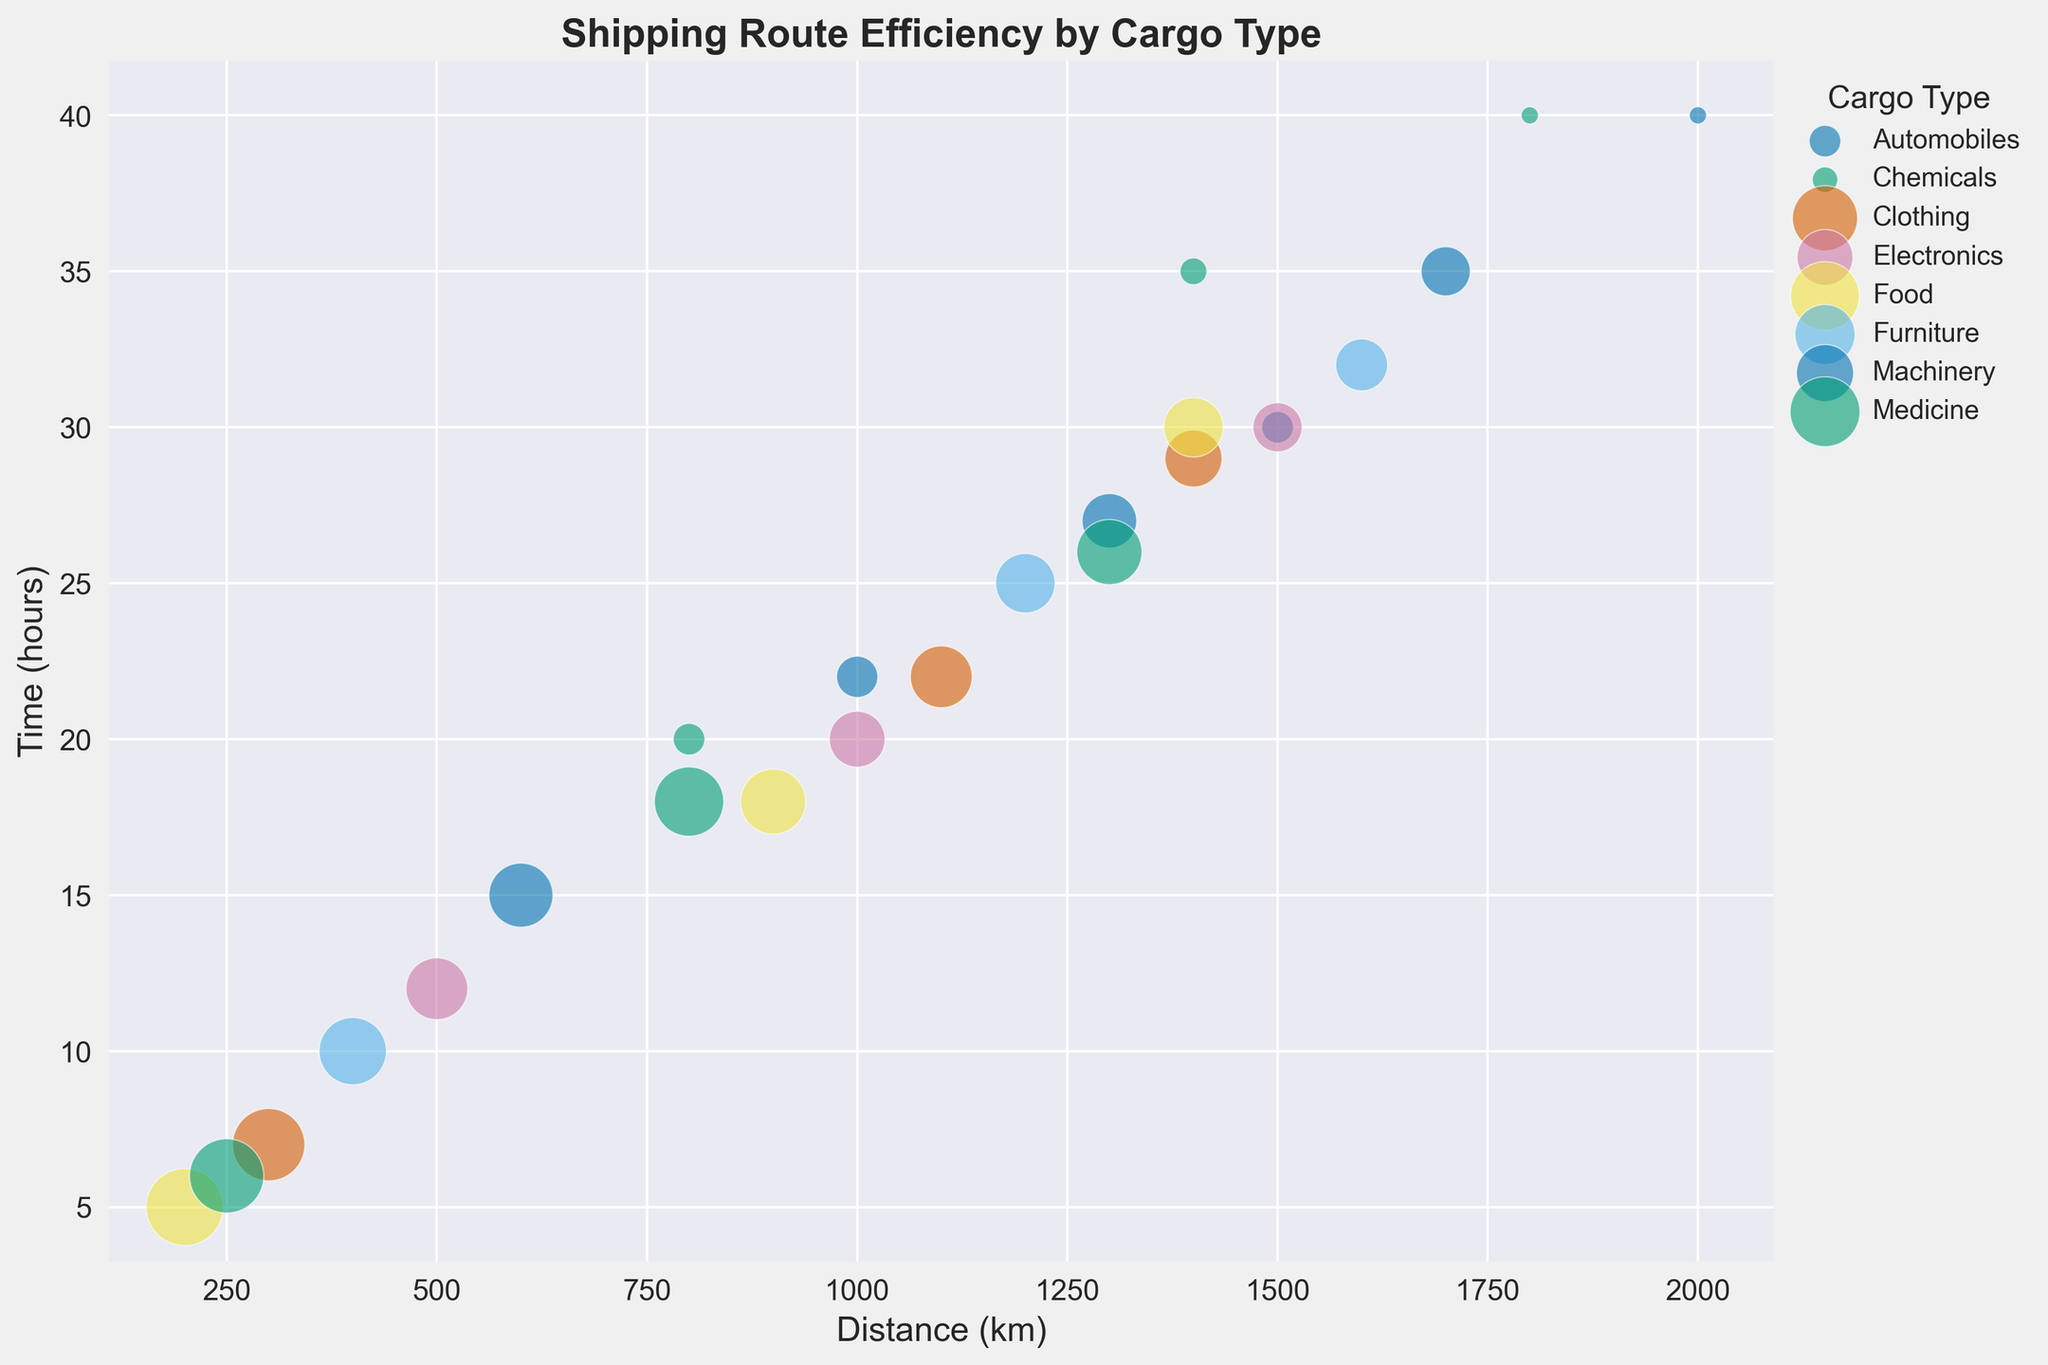What cargo type demonstrates the highest shipping efficiency for short distances? Look for the bubbles positioned at short distances with the largest sizes representing high efficiency scores. The Food cargo type has the largest bubble at a short distance of 200 km with an efficiency score of 95.
Answer: Food Between Electronics and Furniture, which cargo type has a better efficiency score for a similar distance? Compare the bubbles for both cargo types at similar distances. At 1500 km, Electronics has an efficiency score of 70, while Furniture has an efficiency score of 72 at 1600 km.
Answer: Furniture What is the total efficiency score of Food cargo for its data points? Identify the efficiency scores for all the Food cargo data points and add them. The scores are 95, 83, and 78. Sum these scores: 95 + 83 + 78 = 256.
Answer: 256 How does Medicine's average efficiency compare to that of Chemicals? Calculate the average efficiency for both cargo types. Medicine has scores of 92, 87, and 83, averaging (92 + 87 + 83) / 3 = 87.33. Chemicals have scores of 60, 58, and 55, averaging (60 + 58 + 55) / 3 = 57.67. Compare the two averages.
Answer: Medicine's average is higher by 29.66 Does Food or Electronics cargo show a larger difference in efficiency between the shortest and longest distances? For Food, the difference is 95 - 78 = 17. For Electronics, the difference is 80 - 70 = 10. Compare these differences to determine which is larger.
Answer: Food Which cargo type has the longest shipping time for the longest distance? Identify the longest distance and find the corresponding shipping time. The longest distance is 2000 km, and Automobiles at this distance have a time of 40 hours.
Answer: Automobiles At 800 km, which cargo type has the highest efficiency score? Look at the efficiency scores for bubbles located around 800 km. Both Medicine and Chemicals are at this distance, with scores of 87 and 60, respectively.
Answer: Medicine What is the time range (difference between maximum and minimum time) for Clothing cargo? Find the maximum and minimum times for Clothing cargo, which are 29 and 7 hours, respectively. Calculate the range: 29 - 7 = 22 hours.
Answer: 22 hours Which two cargo types provide the highest efficiency at approximately 1000 km distance? Compare the efficiency scores at or near 1000 km. Electronics, Furniture, and Automobiles have scores of 75, 78, and 65, respectively.
Answer: Furniture and Electronics For Medicine cargo, by how much does the shipping time increase from the shortest to the longest distance? Identify Medicine's shortest and longest distances, with corresponding times of 6 and 26 hours. Calculate the increase: 26 - 6 = 20 hours.
Answer: 20 hours 